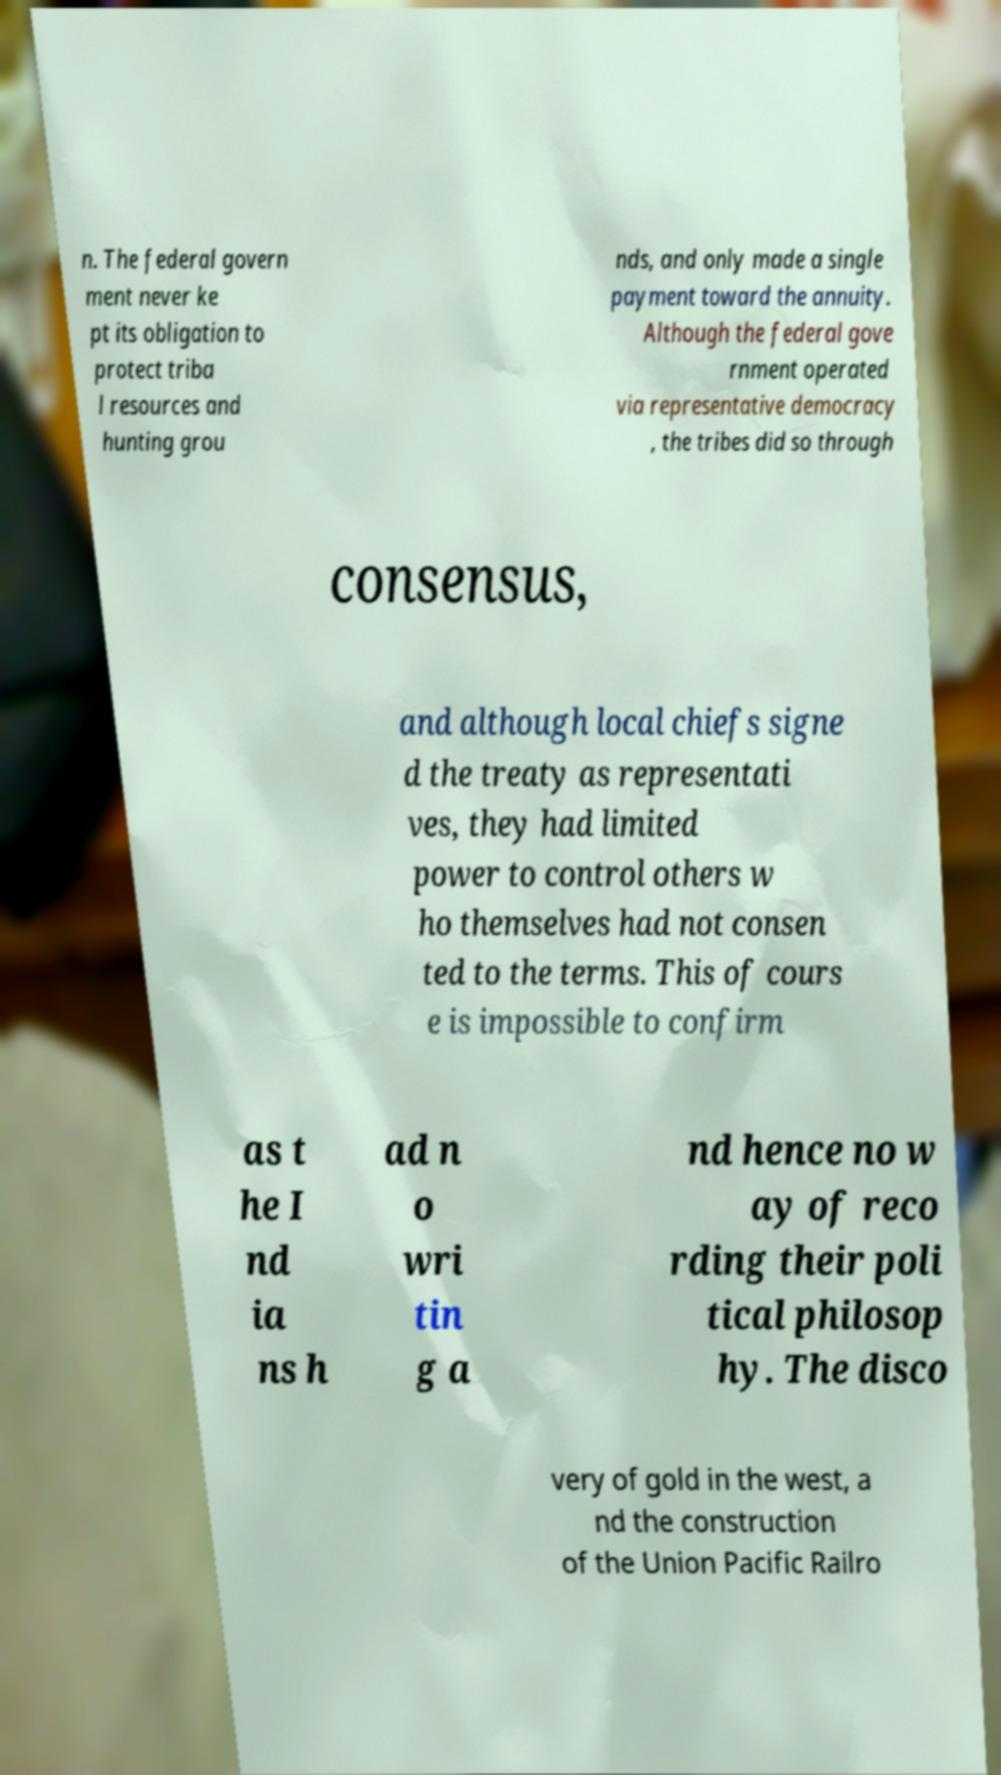Can you accurately transcribe the text from the provided image for me? n. The federal govern ment never ke pt its obligation to protect triba l resources and hunting grou nds, and only made a single payment toward the annuity. Although the federal gove rnment operated via representative democracy , the tribes did so through consensus, and although local chiefs signe d the treaty as representati ves, they had limited power to control others w ho themselves had not consen ted to the terms. This of cours e is impossible to confirm as t he I nd ia ns h ad n o wri tin g a nd hence no w ay of reco rding their poli tical philosop hy. The disco very of gold in the west, a nd the construction of the Union Pacific Railro 